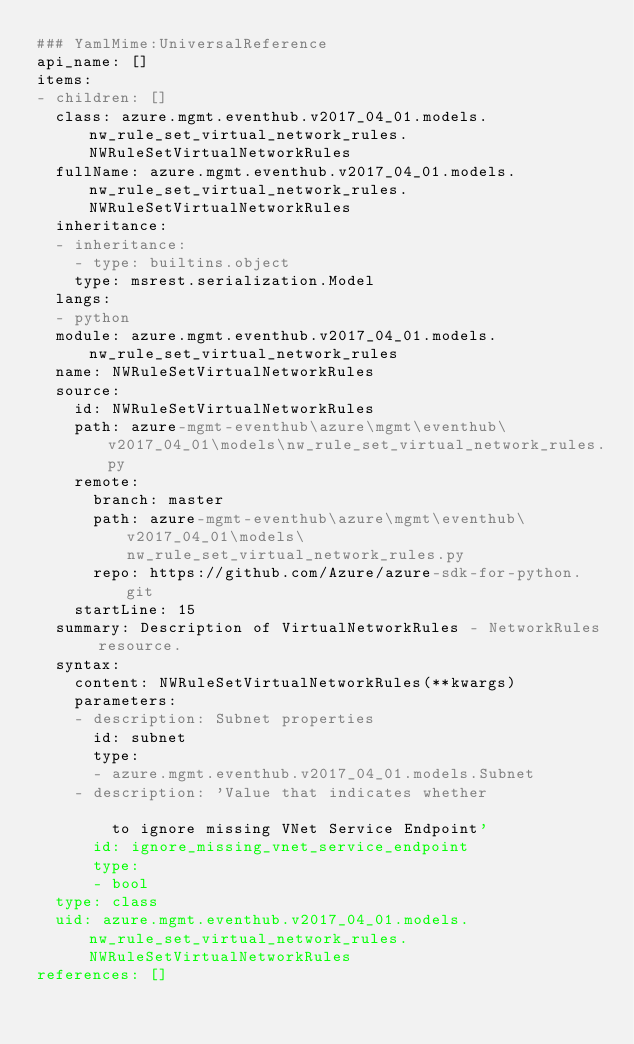<code> <loc_0><loc_0><loc_500><loc_500><_YAML_>### YamlMime:UniversalReference
api_name: []
items:
- children: []
  class: azure.mgmt.eventhub.v2017_04_01.models.nw_rule_set_virtual_network_rules.NWRuleSetVirtualNetworkRules
  fullName: azure.mgmt.eventhub.v2017_04_01.models.nw_rule_set_virtual_network_rules.NWRuleSetVirtualNetworkRules
  inheritance:
  - inheritance:
    - type: builtins.object
    type: msrest.serialization.Model
  langs:
  - python
  module: azure.mgmt.eventhub.v2017_04_01.models.nw_rule_set_virtual_network_rules
  name: NWRuleSetVirtualNetworkRules
  source:
    id: NWRuleSetVirtualNetworkRules
    path: azure-mgmt-eventhub\azure\mgmt\eventhub\v2017_04_01\models\nw_rule_set_virtual_network_rules.py
    remote:
      branch: master
      path: azure-mgmt-eventhub\azure\mgmt\eventhub\v2017_04_01\models\nw_rule_set_virtual_network_rules.py
      repo: https://github.com/Azure/azure-sdk-for-python.git
    startLine: 15
  summary: Description of VirtualNetworkRules - NetworkRules resource.
  syntax:
    content: NWRuleSetVirtualNetworkRules(**kwargs)
    parameters:
    - description: Subnet properties
      id: subnet
      type:
      - azure.mgmt.eventhub.v2017_04_01.models.Subnet
    - description: 'Value that indicates whether

        to ignore missing VNet Service Endpoint'
      id: ignore_missing_vnet_service_endpoint
      type:
      - bool
  type: class
  uid: azure.mgmt.eventhub.v2017_04_01.models.nw_rule_set_virtual_network_rules.NWRuleSetVirtualNetworkRules
references: []
</code> 